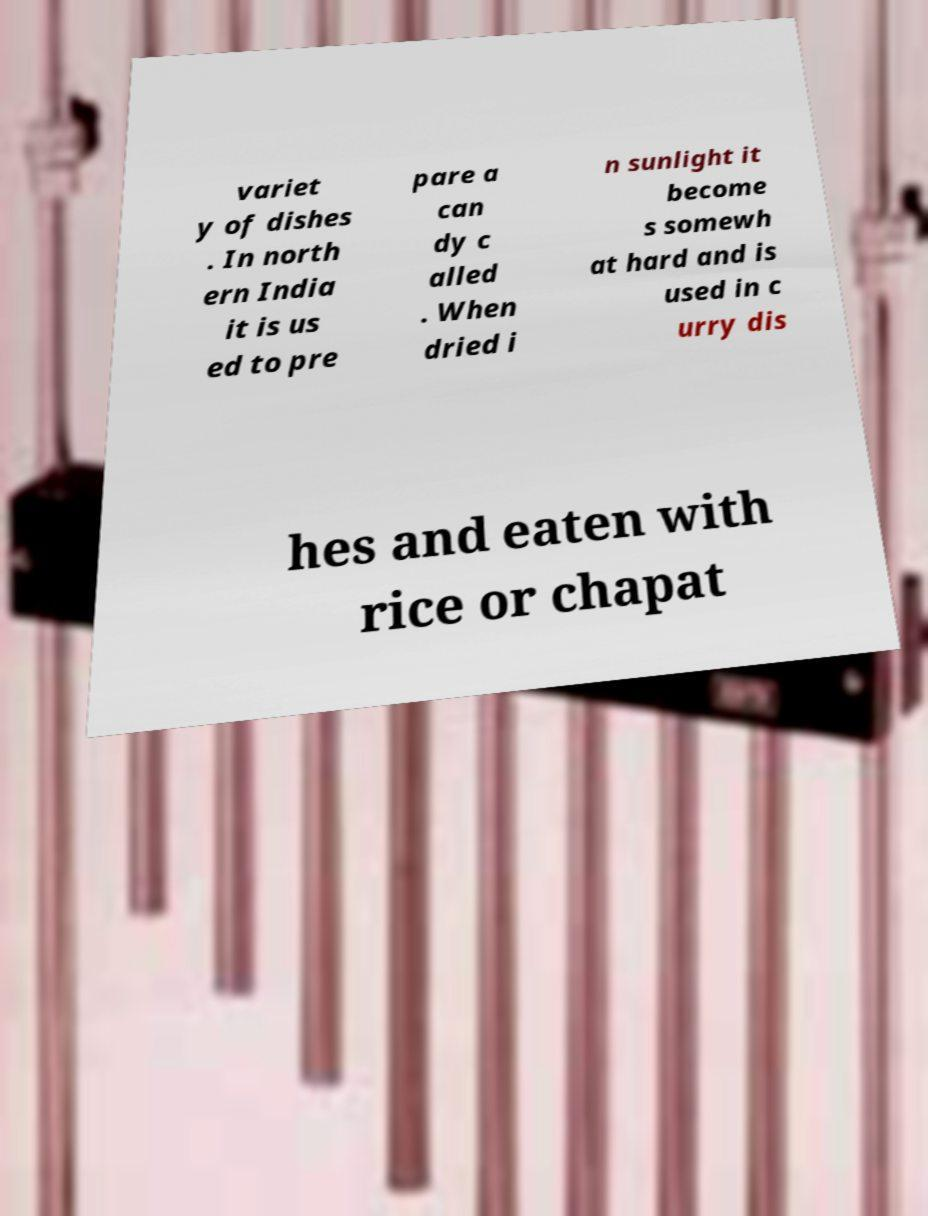Can you read and provide the text displayed in the image?This photo seems to have some interesting text. Can you extract and type it out for me? variet y of dishes . In north ern India it is us ed to pre pare a can dy c alled . When dried i n sunlight it become s somewh at hard and is used in c urry dis hes and eaten with rice or chapat 